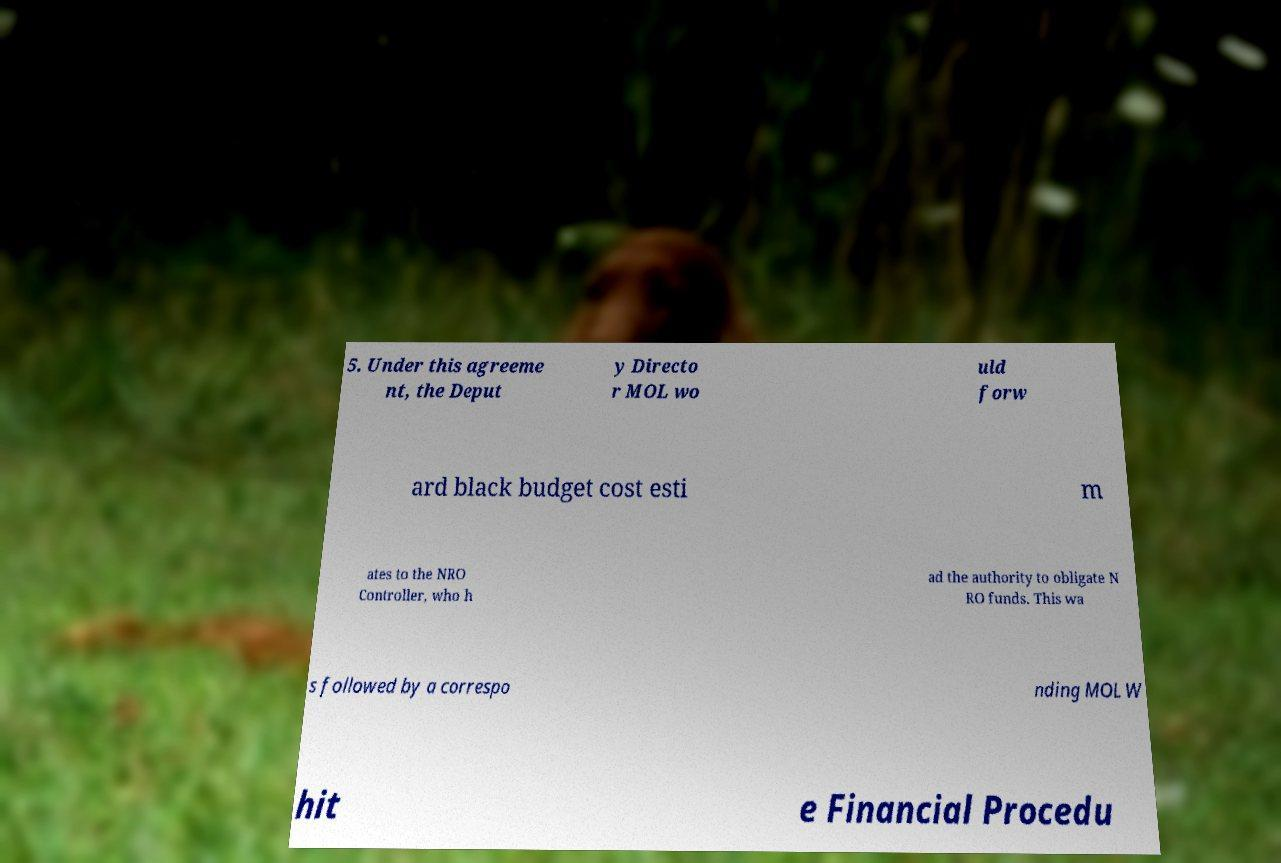Could you assist in decoding the text presented in this image and type it out clearly? 5. Under this agreeme nt, the Deput y Directo r MOL wo uld forw ard black budget cost esti m ates to the NRO Controller, who h ad the authority to obligate N RO funds. This wa s followed by a correspo nding MOL W hit e Financial Procedu 